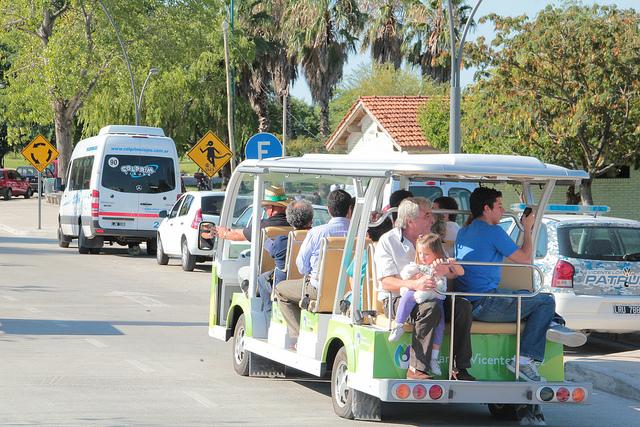How many doors are on this vehicle?
Answer briefly. 0. How many people are in this vehicle?
Be succinct. 12. What type of scene is this?
Write a very short answer. Street. 